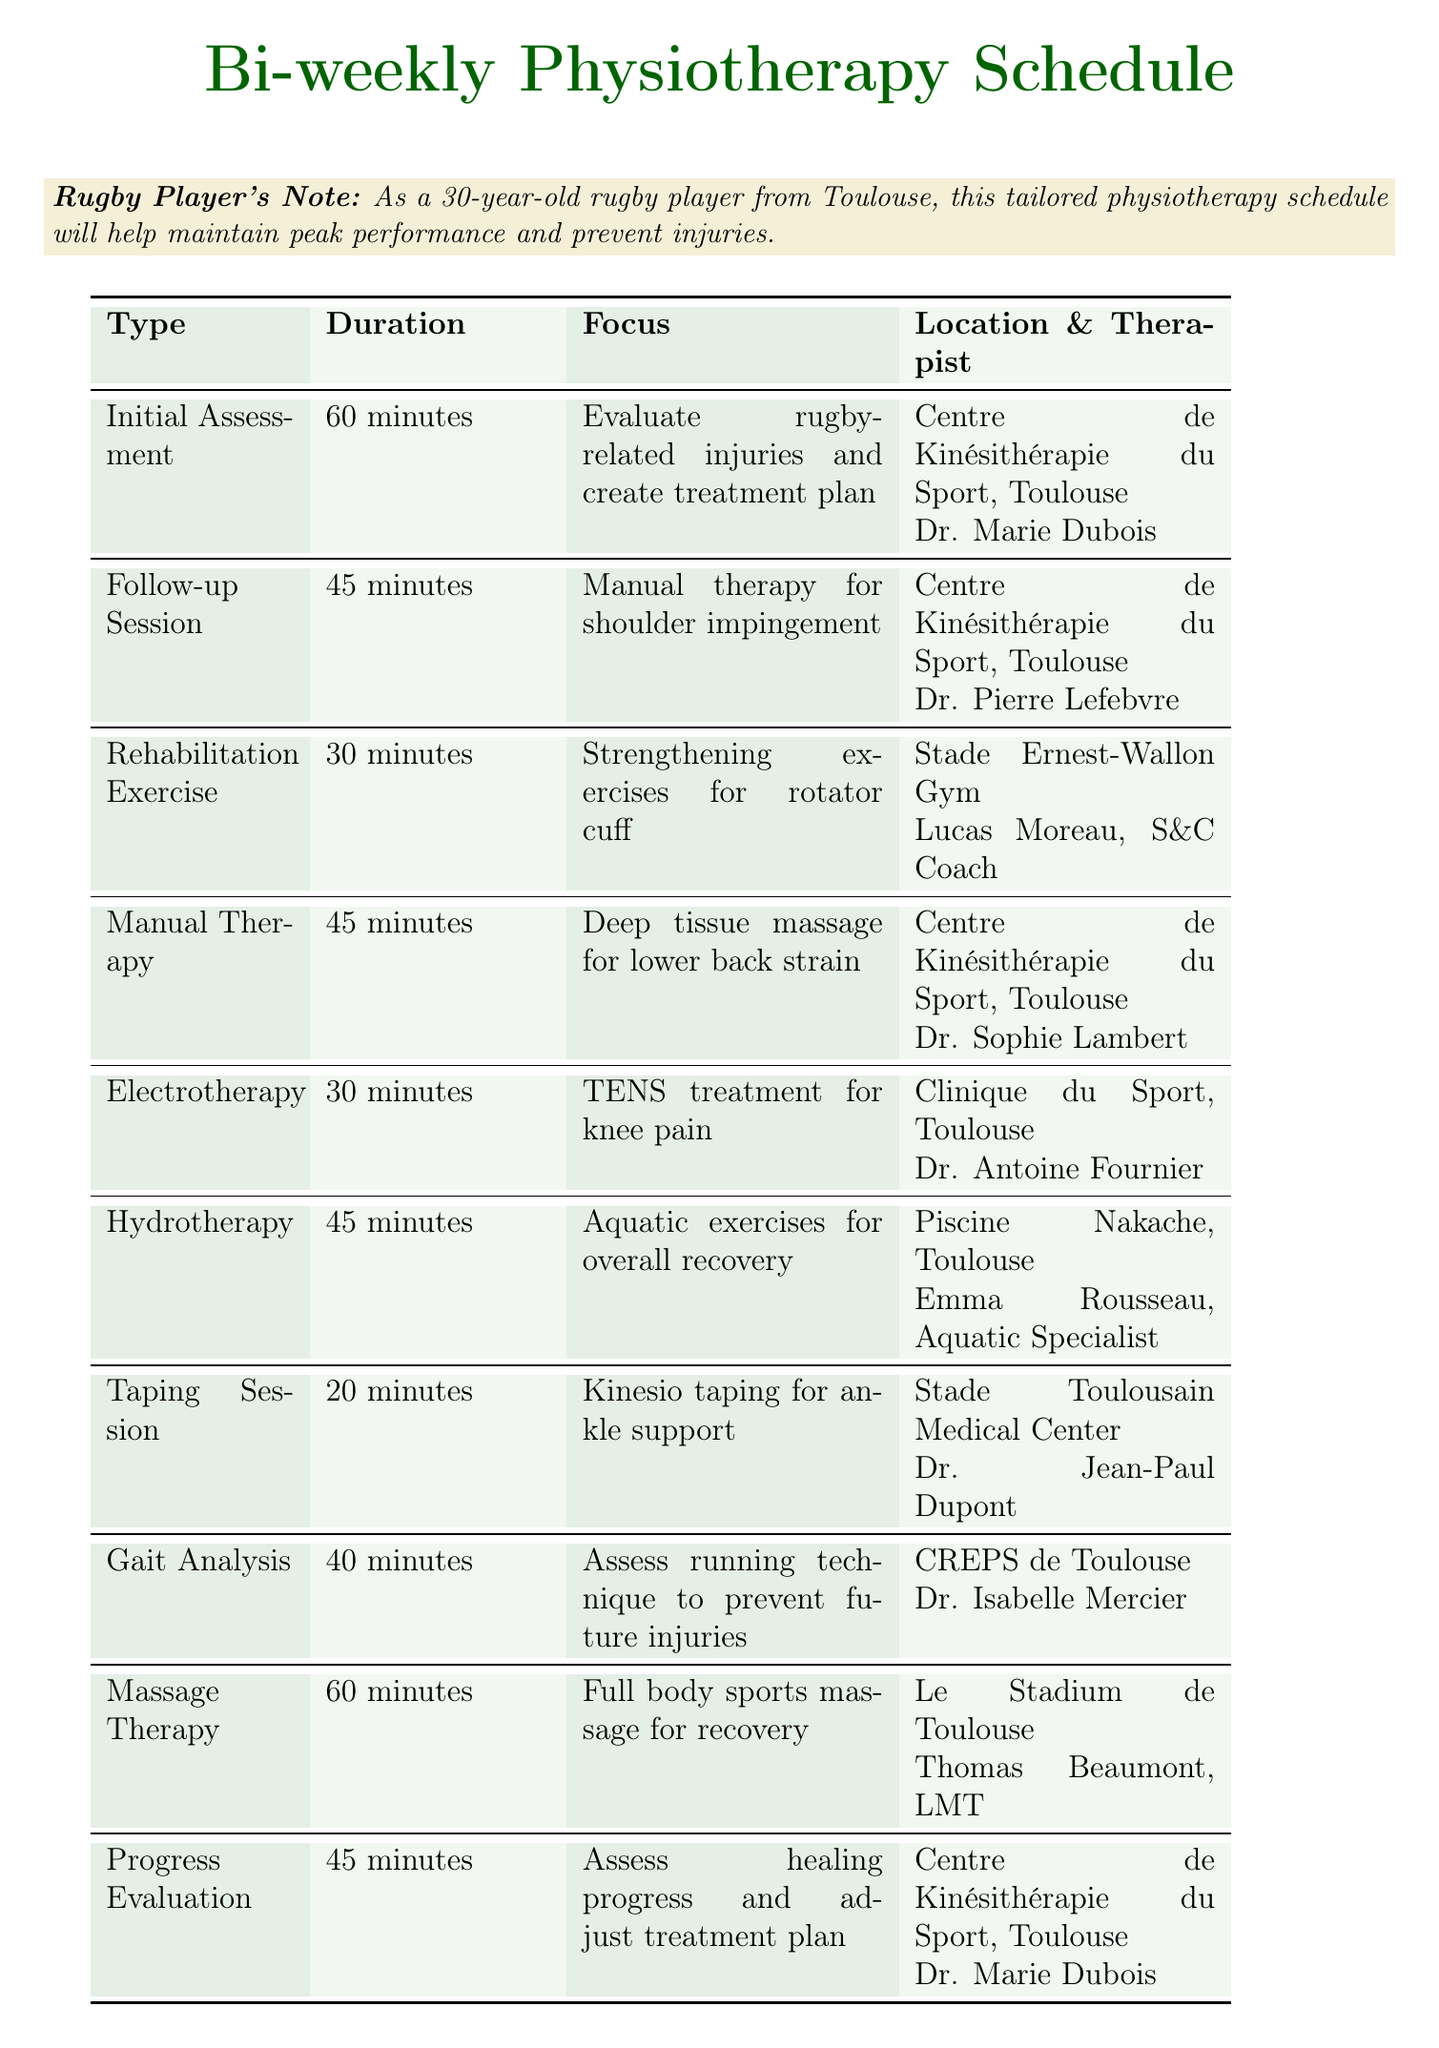What is the duration of the Initial Assessment? The duration of the Initial Assessment is stated directly in the document.
Answer: 60 minutes Who is the therapist for the Hydrotherapy session? The therapist for Hydrotherapy is listed in the document along with the session details.
Answer: Emma Rousseau, Aquatic Therapy Specialist What injury is being addressed in the Follow-up Session? The focus of the Follow-up Session provides information about the injury addressed.
Answer: Shoulder impingement Where is the Gait Analysis conducted? The location for Gait Analysis is specified in the document.
Answer: CREPS de Toulouse How long is the Massage Therapy session? The duration of the Massage Therapy session can be found in the schedule.
Answer: 60 minutes What type of therapy is provided for knee pain? The focus mentioned for the Electrotherapy session indicates the type of treatment.
Answer: TENS treatment What is a recommended action during rehabilitation sessions? The note at the end of the document offers advice related to physiotherapy sessions.
Answer: Bring your rugby kit How often are appointments scheduled? The title of the document specifies the frequency of the appointments.
Answer: Bi-weekly What is the location for the Progress Evaluation? The location for Progress Evaluation is provided in the schedule.
Answer: Centre de Kinésithérapie du Sport, Toulouse 